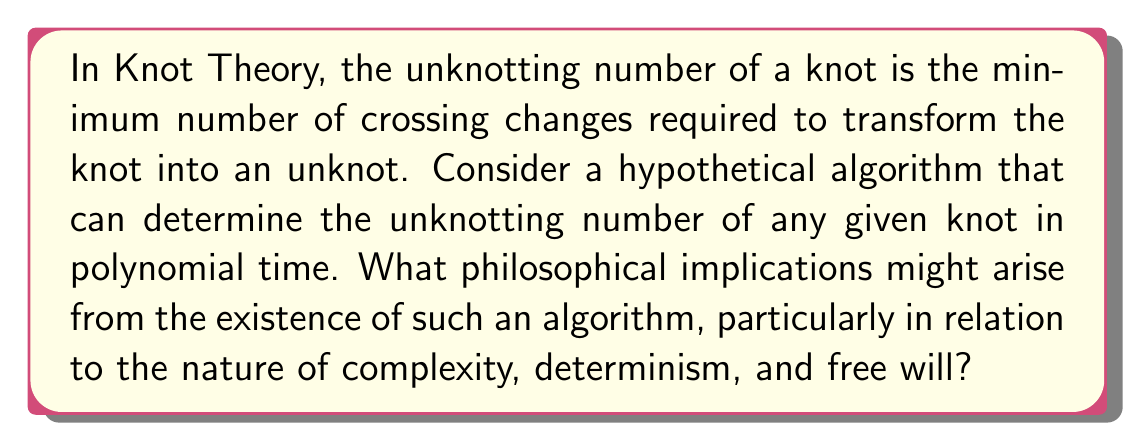What is the answer to this math problem? To approach this question, let's break it down into steps that connect Knot Theory with philosophical concepts:

1. Understanding the unknotting number:
   The unknotting number $u(K)$ for a knot $K$ is defined as:
   $$u(K) = \min\{n \in \mathbb{N} : K \text{ can be transformed into an unknot with } n \text{ crossing changes}\}$$

2. Implications of a polynomial-time algorithm:
   If such an algorithm existed, it would solve the unknotting problem efficiently, which is currently believed to be NP-hard.

3. Complexity and determinism:
   The existence of this algorithm would suggest that the apparent complexity of knots is illusory, and that there's a deterministic structure underlying even the most complex-looking knots.

4. Free will and decision-making:
   If knot simplification can be reduced to a deterministic process, it raises questions about whether human decision-making in complex situations is truly free or simply a complex deterministic process we haven't yet decoded.

5. Nature of reality:
   The algorithm's existence might imply that reality, like knots, has an underlying simplicity that we perceive as complex due to our limited understanding.

6. Ethical considerations:
   If complex systems can be simplified efficiently, it raises ethical questions about the value we place on human intuition and creativity in problem-solving.

7. Limits of knowledge:
   The algorithm's existence would challenge our understanding of the limits of computational knowledge and might necessitate a re-evaluation of what we consider "unsolvable" problems.

Philosophical implications:
- Determinism vs. free will in decision-making processes
- The nature of complexity and our perception of it
- The relationship between computational efficiency and ethical considerations in problem-solving
- The potential limits (or lack thereof) of human and machine knowledge
Answer: Challenges notions of free will, complexity, and knowledge limits; raises ethical questions about human intuition in problem-solving. 